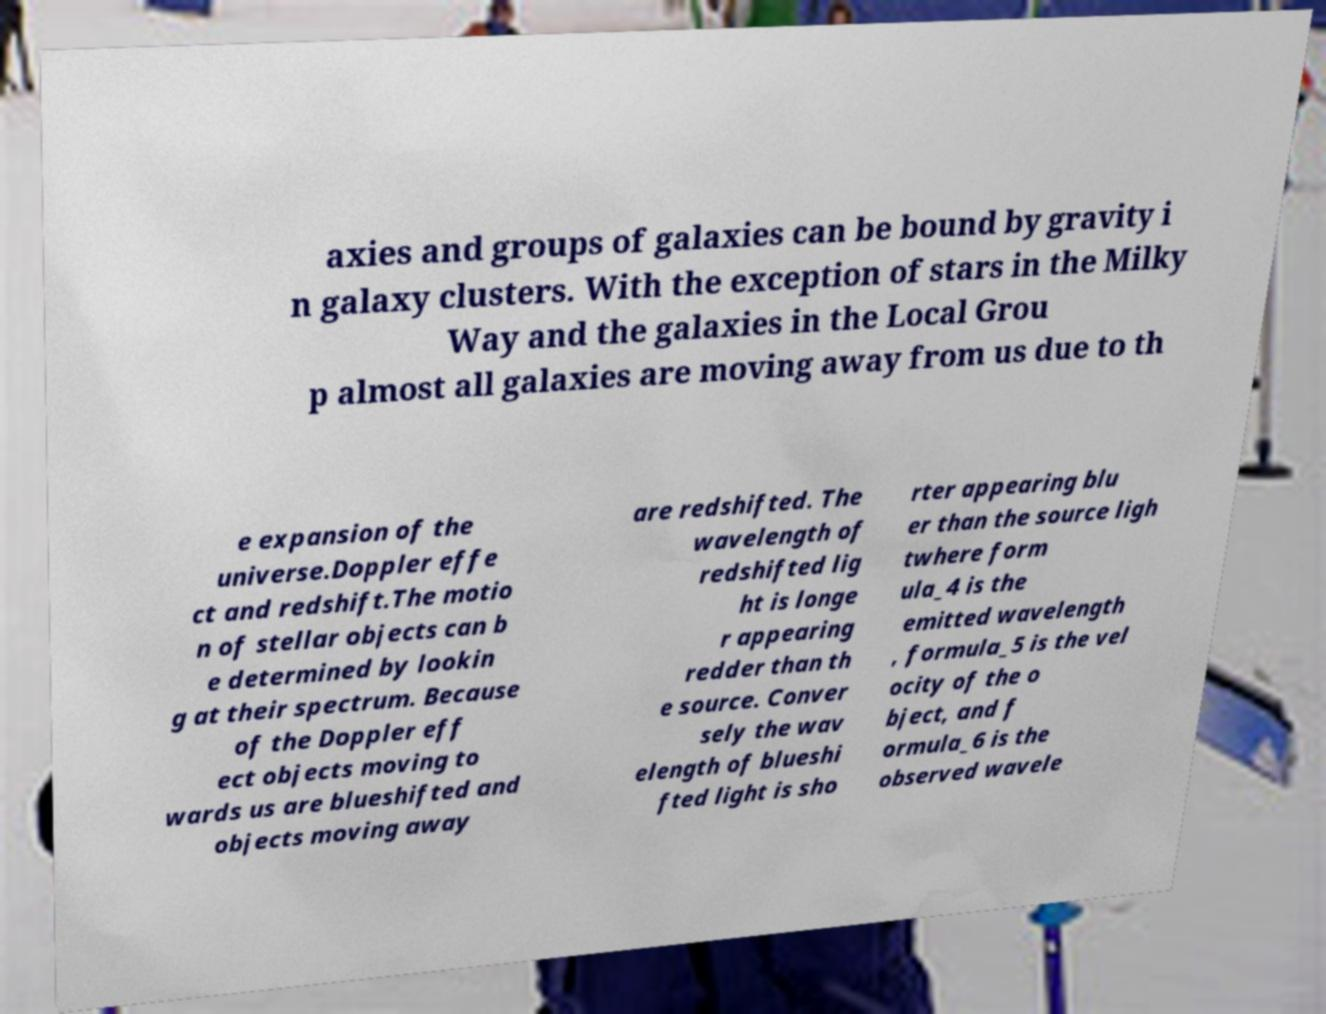Can you accurately transcribe the text from the provided image for me? axies and groups of galaxies can be bound by gravity i n galaxy clusters. With the exception of stars in the Milky Way and the galaxies in the Local Grou p almost all galaxies are moving away from us due to th e expansion of the universe.Doppler effe ct and redshift.The motio n of stellar objects can b e determined by lookin g at their spectrum. Because of the Doppler eff ect objects moving to wards us are blueshifted and objects moving away are redshifted. The wavelength of redshifted lig ht is longe r appearing redder than th e source. Conver sely the wav elength of blueshi fted light is sho rter appearing blu er than the source ligh twhere form ula_4 is the emitted wavelength , formula_5 is the vel ocity of the o bject, and f ormula_6 is the observed wavele 